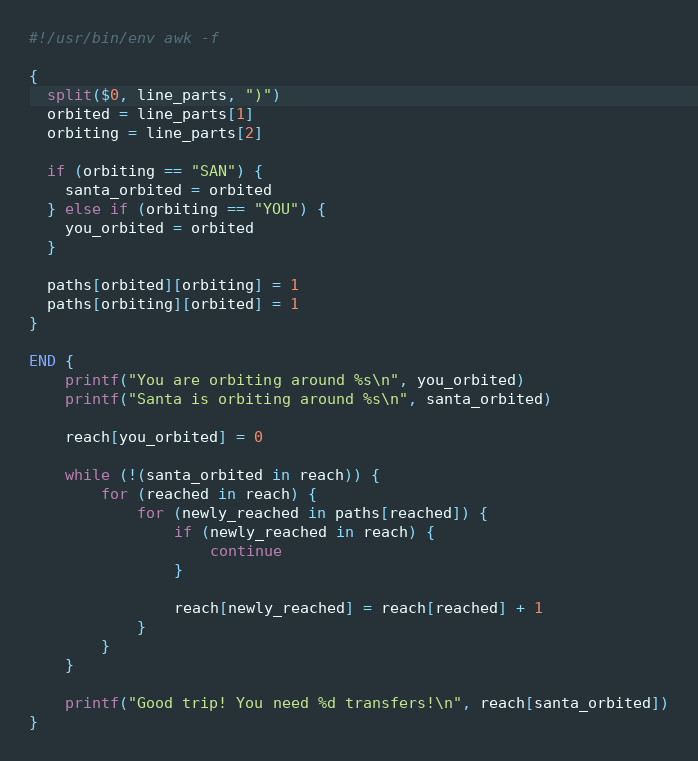<code> <loc_0><loc_0><loc_500><loc_500><_Awk_>#!/usr/bin/env awk -f

{
  split($0, line_parts, ")")
  orbited = line_parts[1]
  orbiting = line_parts[2]

  if (orbiting == "SAN") {
    santa_orbited = orbited
  } else if (orbiting == "YOU") {
    you_orbited = orbited
  }

  paths[orbited][orbiting] = 1
  paths[orbiting][orbited] = 1
}

END {
    printf("You are orbiting around %s\n", you_orbited)
    printf("Santa is orbiting around %s\n", santa_orbited)

    reach[you_orbited] = 0

    while (!(santa_orbited in reach)) {
        for (reached in reach) {
            for (newly_reached in paths[reached]) {
                if (newly_reached in reach) {
                    continue
                }

                reach[newly_reached] = reach[reached] + 1
            }
        }
    }

    printf("Good trip! You need %d transfers!\n", reach[santa_orbited])
}
</code> 